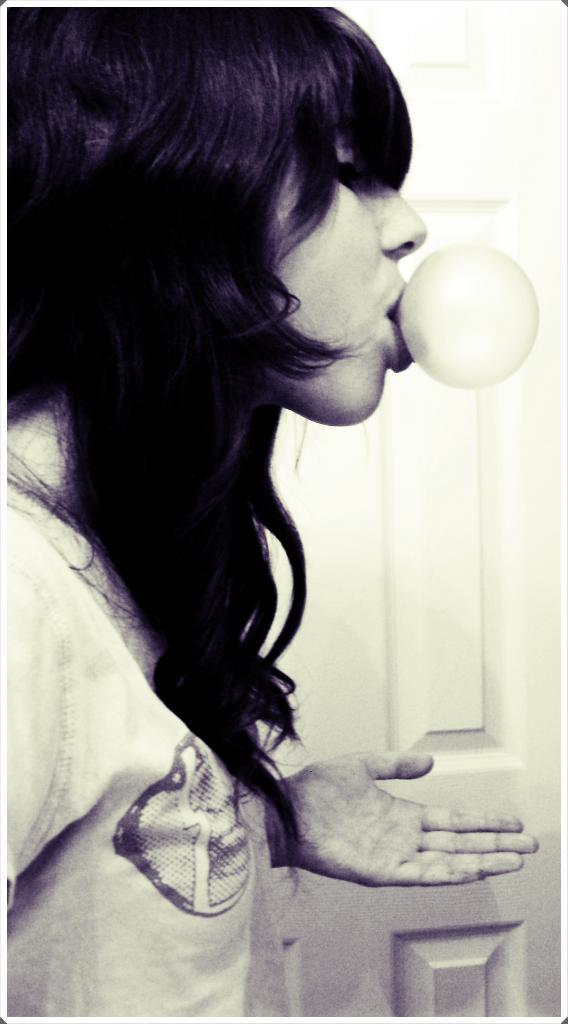What is the color scheme of the image? The image is black and white. Who is present in the image? There is a woman in the image. What is the woman doing in the image? The woman is standing and chewing bubble gum. What is the woman wearing in the image? The woman is wearing a T-shirt. What type of door can be seen in the image? There is a wooden door in the image. What type of payment is required to attend the school in the image? There is no school present in the image, so no payment is required. How long does the woman rest in the image? The woman is not resting in the image; she is standing and chewing bubble gum. 